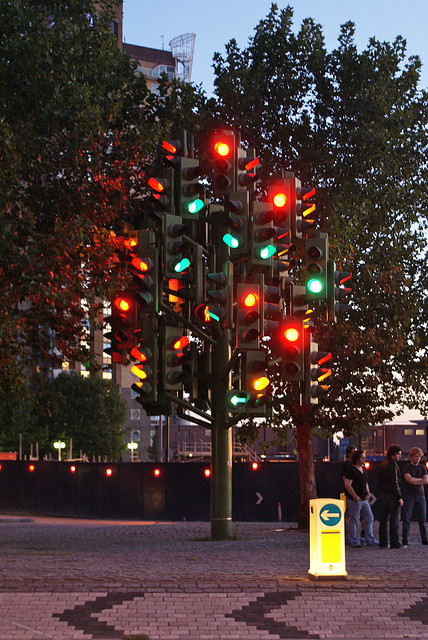<image>What is the name of the business with the yellow sign? I don't know the name of the business with the yellow sign. It is not specified in the details. What is the name of the business with the yellow sign? I don't know the name of the business with the yellow sign. It can be taxi, city, metro, arrow, or metro and transit. 